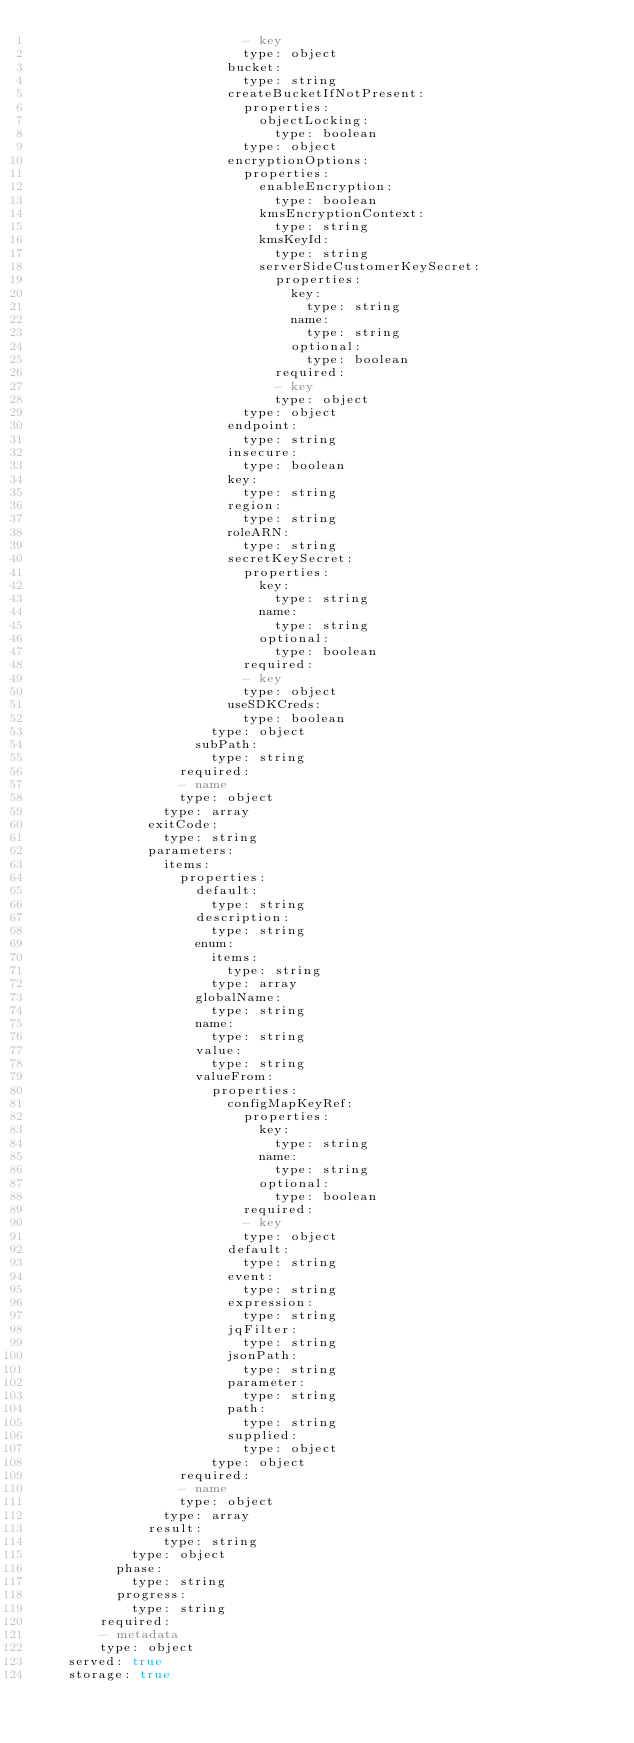Convert code to text. <code><loc_0><loc_0><loc_500><loc_500><_YAML_>                          - key
                          type: object
                        bucket:
                          type: string
                        createBucketIfNotPresent:
                          properties:
                            objectLocking:
                              type: boolean
                          type: object
                        encryptionOptions:
                          properties:
                            enableEncryption:
                              type: boolean
                            kmsEncryptionContext:
                              type: string
                            kmsKeyId:
                              type: string
                            serverSideCustomerKeySecret:
                              properties:
                                key:
                                  type: string
                                name:
                                  type: string
                                optional:
                                  type: boolean
                              required:
                              - key
                              type: object
                          type: object
                        endpoint:
                          type: string
                        insecure:
                          type: boolean
                        key:
                          type: string
                        region:
                          type: string
                        roleARN:
                          type: string
                        secretKeySecret:
                          properties:
                            key:
                              type: string
                            name:
                              type: string
                            optional:
                              type: boolean
                          required:
                          - key
                          type: object
                        useSDKCreds:
                          type: boolean
                      type: object
                    subPath:
                      type: string
                  required:
                  - name
                  type: object
                type: array
              exitCode:
                type: string
              parameters:
                items:
                  properties:
                    default:
                      type: string
                    description:
                      type: string
                    enum:
                      items:
                        type: string
                      type: array
                    globalName:
                      type: string
                    name:
                      type: string
                    value:
                      type: string
                    valueFrom:
                      properties:
                        configMapKeyRef:
                          properties:
                            key:
                              type: string
                            name:
                              type: string
                            optional:
                              type: boolean
                          required:
                          - key
                          type: object
                        default:
                          type: string
                        event:
                          type: string
                        expression:
                          type: string
                        jqFilter:
                          type: string
                        jsonPath:
                          type: string
                        parameter:
                          type: string
                        path:
                          type: string
                        supplied:
                          type: object
                      type: object
                  required:
                  - name
                  type: object
                type: array
              result:
                type: string
            type: object
          phase:
            type: string
          progress:
            type: string
        required:
        - metadata
        type: object
    served: true
    storage: true
</code> 